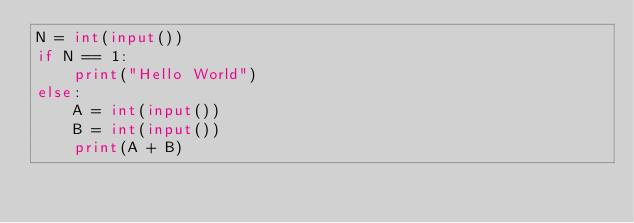<code> <loc_0><loc_0><loc_500><loc_500><_Python_>N = int(input())
if N == 1:
    print("Hello World")
else:
    A = int(input())
    B = int(input())
    print(A + B)</code> 